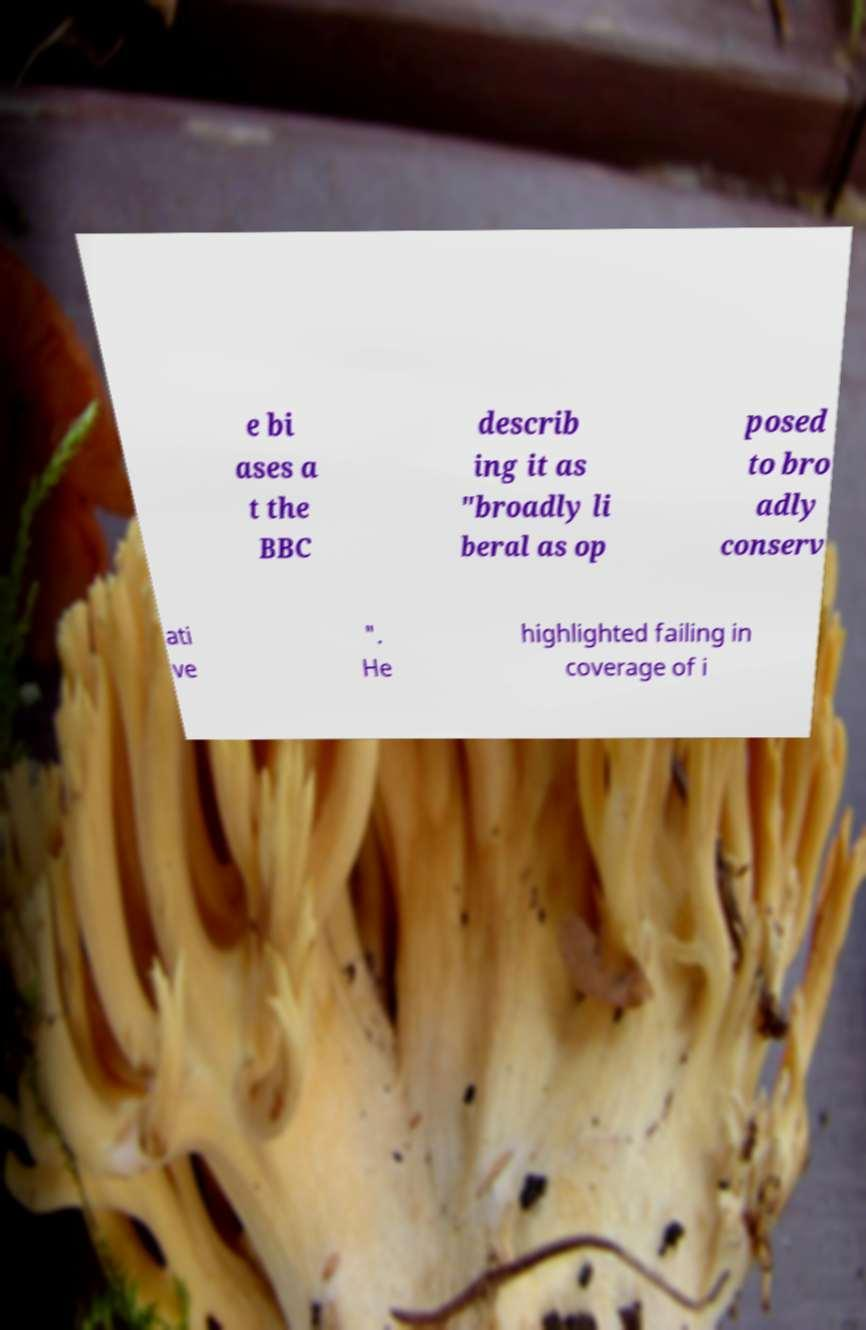I need the written content from this picture converted into text. Can you do that? e bi ases a t the BBC describ ing it as "broadly li beral as op posed to bro adly conserv ati ve ". He highlighted failing in coverage of i 